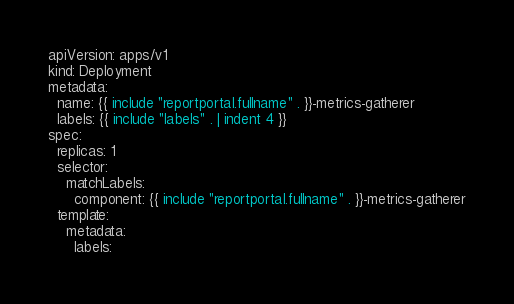Convert code to text. <code><loc_0><loc_0><loc_500><loc_500><_YAML_>apiVersion: apps/v1
kind: Deployment
metadata:
  name: {{ include "reportportal.fullname" . }}-metrics-gatherer
  labels: {{ include "labels" . | indent 4 }}
spec:
  replicas: 1
  selector:
    matchLabels:
      component: {{ include "reportportal.fullname" . }}-metrics-gatherer
  template:
    metadata:
      labels:</code> 